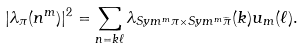<formula> <loc_0><loc_0><loc_500><loc_500>| \lambda _ { \pi } ( n ^ { m } ) | ^ { 2 } = \sum _ { n = k \ell } \lambda _ { S y m ^ { m } \pi \times S y m ^ { m } \widetilde { \pi } } ( k ) u _ { m } ( \ell ) .</formula> 